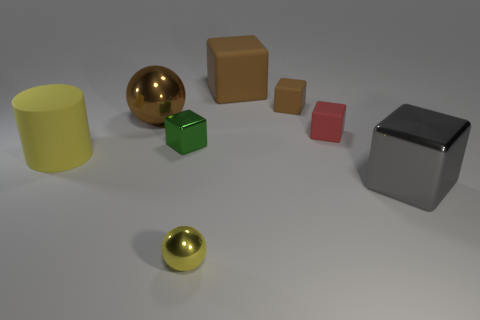How many brown cubes must be subtracted to get 1 brown cubes? 1 Subtract all tiny red blocks. How many blocks are left? 4 Subtract all green blocks. How many blocks are left? 4 Subtract all yellow cubes. Subtract all gray spheres. How many cubes are left? 5 Add 1 blue metallic blocks. How many objects exist? 9 Subtract all blocks. How many objects are left? 3 Subtract all large brown things. Subtract all small green cylinders. How many objects are left? 6 Add 7 red things. How many red things are left? 8 Add 6 tiny brown things. How many tiny brown things exist? 7 Subtract 0 gray cylinders. How many objects are left? 8 